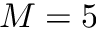<formula> <loc_0><loc_0><loc_500><loc_500>M = 5</formula> 